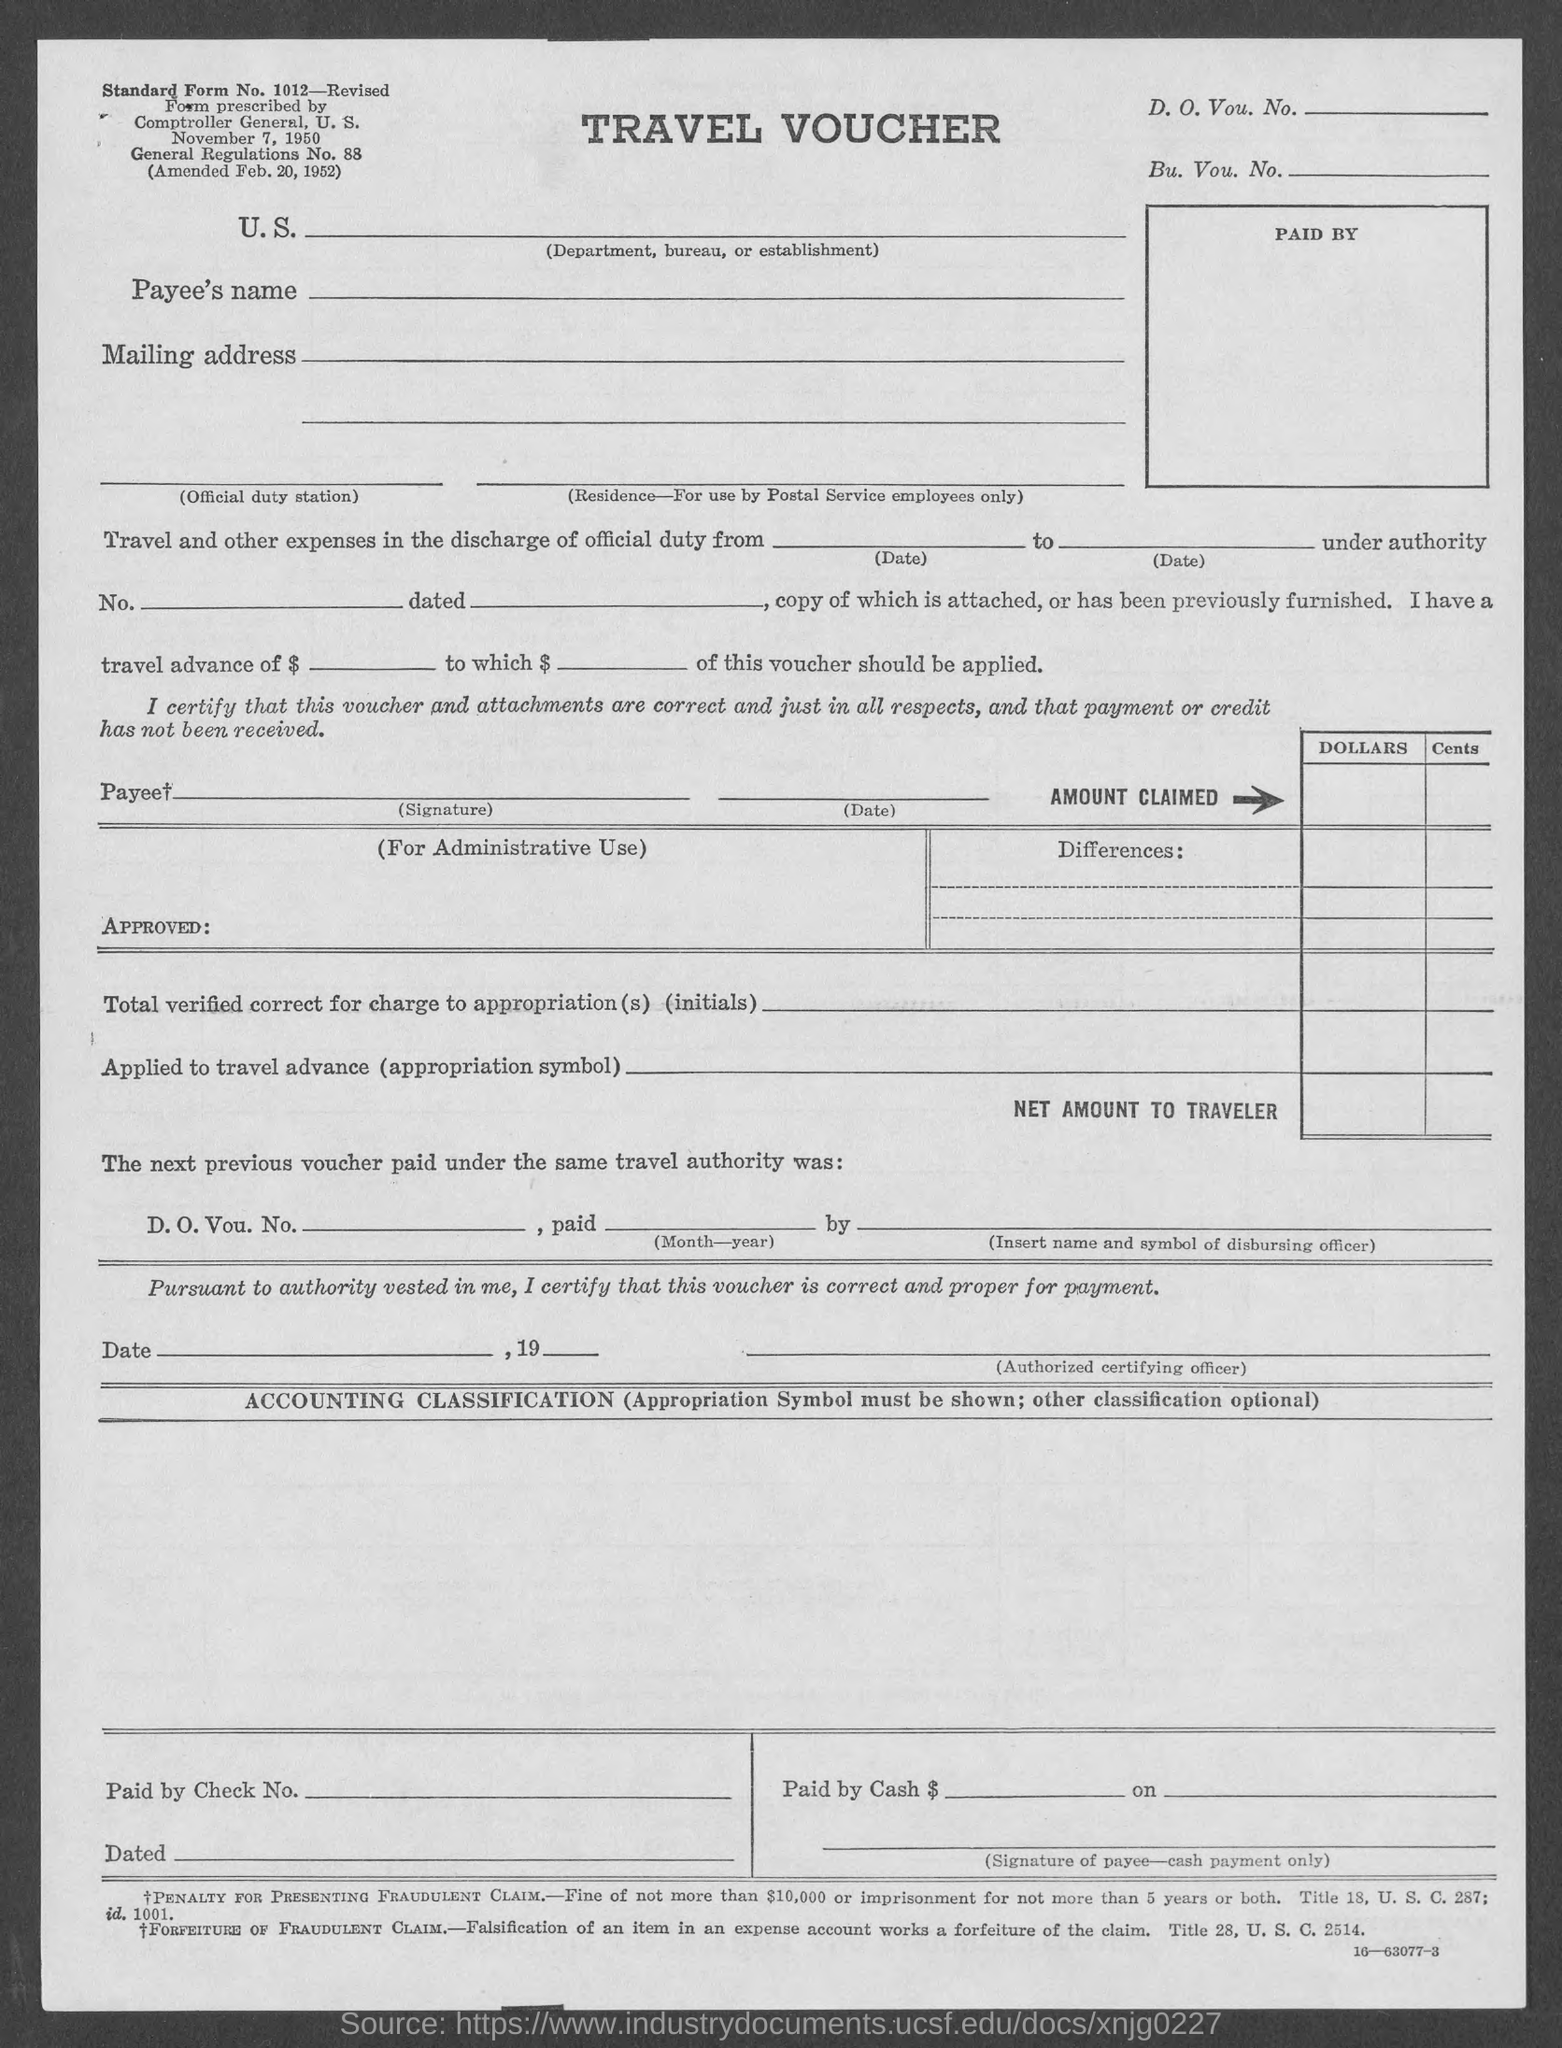Point out several critical features in this image. The standard form number mentioned on the given page is 1012 - Revised. 